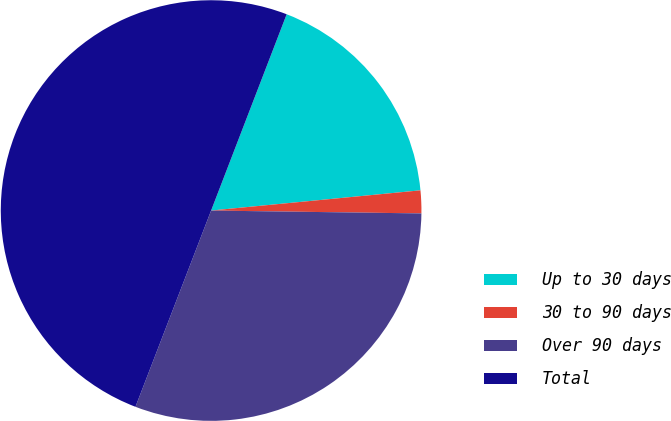Convert chart to OTSL. <chart><loc_0><loc_0><loc_500><loc_500><pie_chart><fcel>Up to 30 days<fcel>30 to 90 days<fcel>Over 90 days<fcel>Total<nl><fcel>17.62%<fcel>1.75%<fcel>30.64%<fcel>50.0%<nl></chart> 